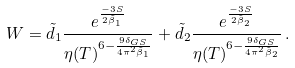Convert formula to latex. <formula><loc_0><loc_0><loc_500><loc_500>W = \tilde { d } _ { 1 } \frac { e ^ { \frac { - 3 S } { 2 \tilde { \beta } _ { 1 } } } } { \eta ( T ) ^ { 6 - \frac { 9 \delta _ { G S } } { 4 \pi ^ { 2 } \tilde { \beta } _ { 1 } } } } + \tilde { d } _ { 2 } \frac { e ^ { \frac { - 3 S } { 2 \tilde { \beta } _ { 2 } } } } { \eta ( T ) ^ { 6 - \frac { 9 \delta _ { G S } } { 4 \pi ^ { 2 } \tilde { \beta } _ { 2 } } } } \, .</formula> 